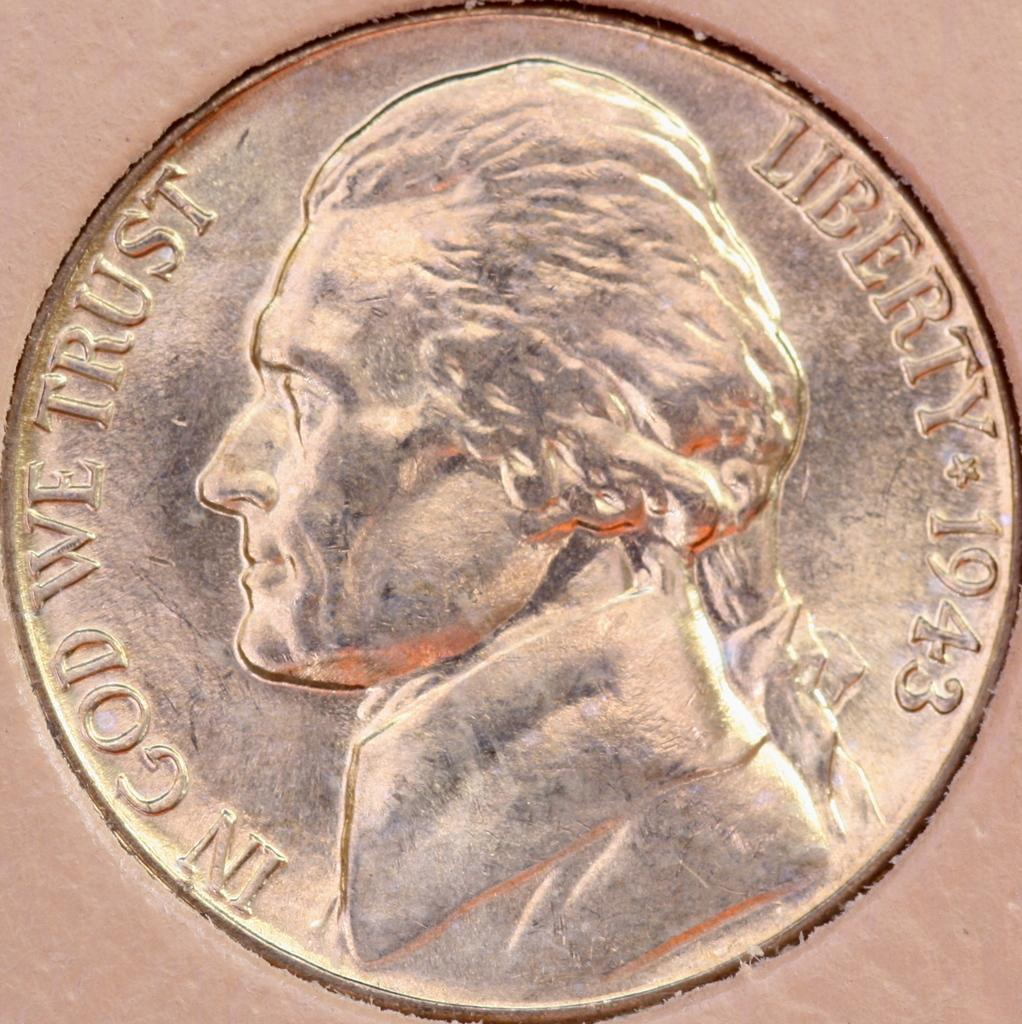Provide a one-sentence caption for the provided image. A coin from 1943 with the phrase In God We Trust and Liberty. 